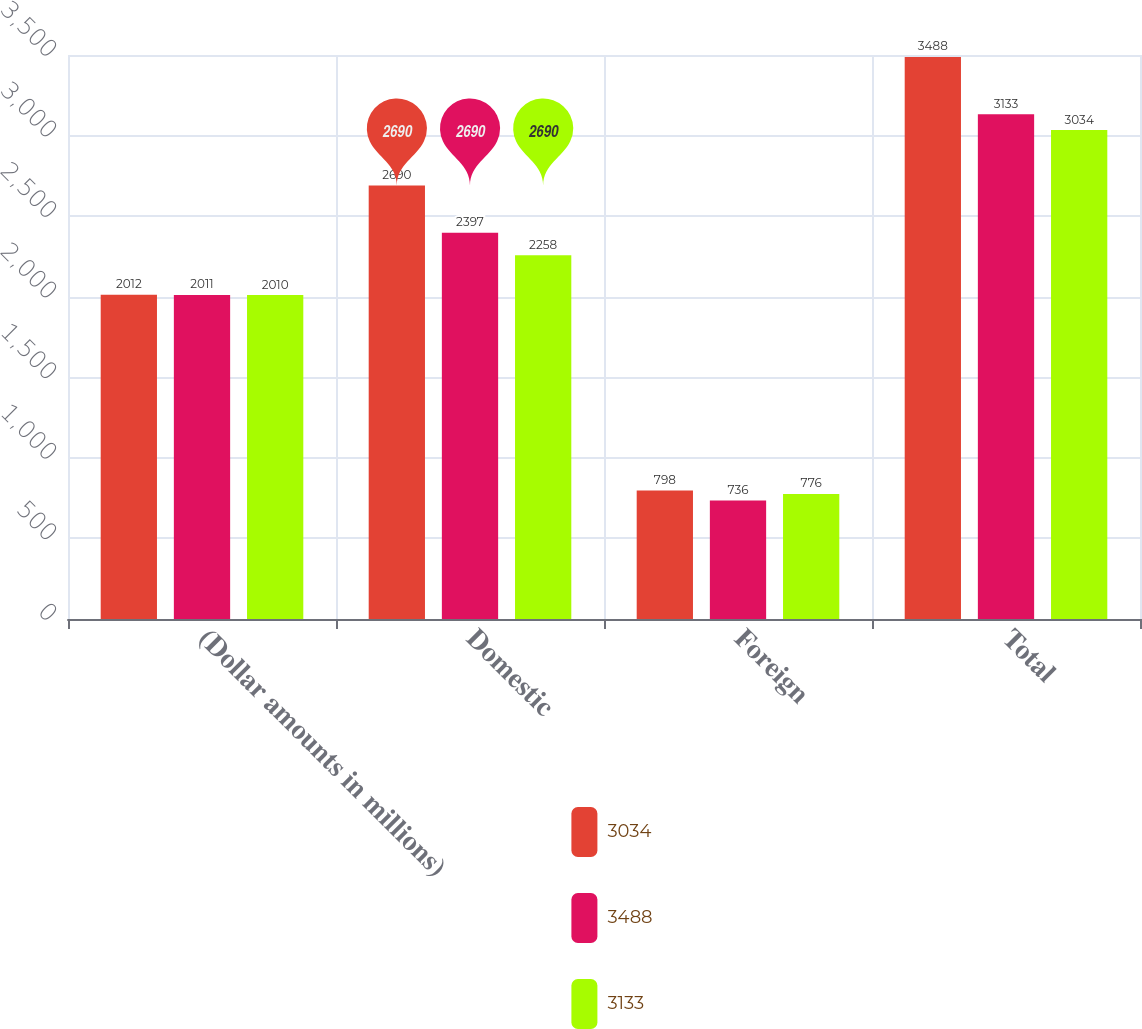<chart> <loc_0><loc_0><loc_500><loc_500><stacked_bar_chart><ecel><fcel>(Dollar amounts in millions)<fcel>Domestic<fcel>Foreign<fcel>Total<nl><fcel>3034<fcel>2012<fcel>2690<fcel>798<fcel>3488<nl><fcel>3488<fcel>2011<fcel>2397<fcel>736<fcel>3133<nl><fcel>3133<fcel>2010<fcel>2258<fcel>776<fcel>3034<nl></chart> 